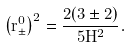<formula> <loc_0><loc_0><loc_500><loc_500>\left ( r _ { \pm } ^ { 0 } \right ) ^ { 2 } = \frac { 2 ( 3 \pm 2 ) } { 5 H ^ { 2 } } .</formula> 